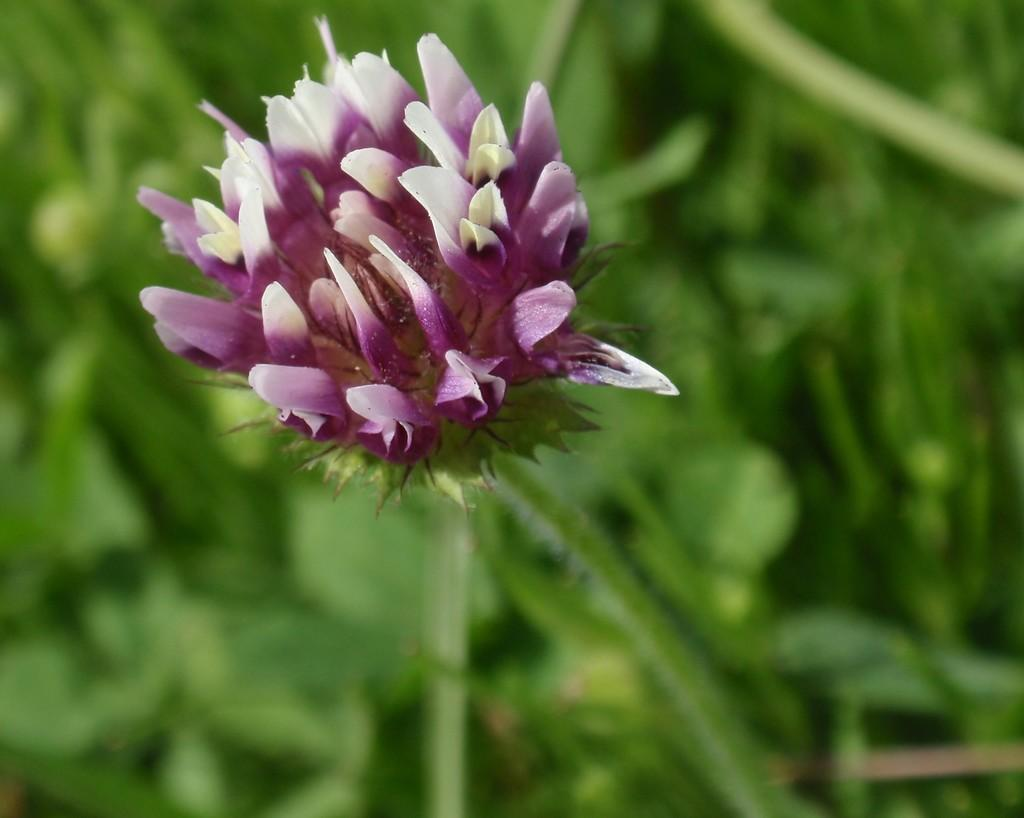What is the main subject of the picture? The main subject of the picture is a flower. Can you describe the colors of the flower? The flower has violet and white colors. What can be seen in the background of the picture? There is greenery in the background of the picture. What type of advice is the flower giving to the person in the picture? There is no person present in the image, and flowers do not give advice. 